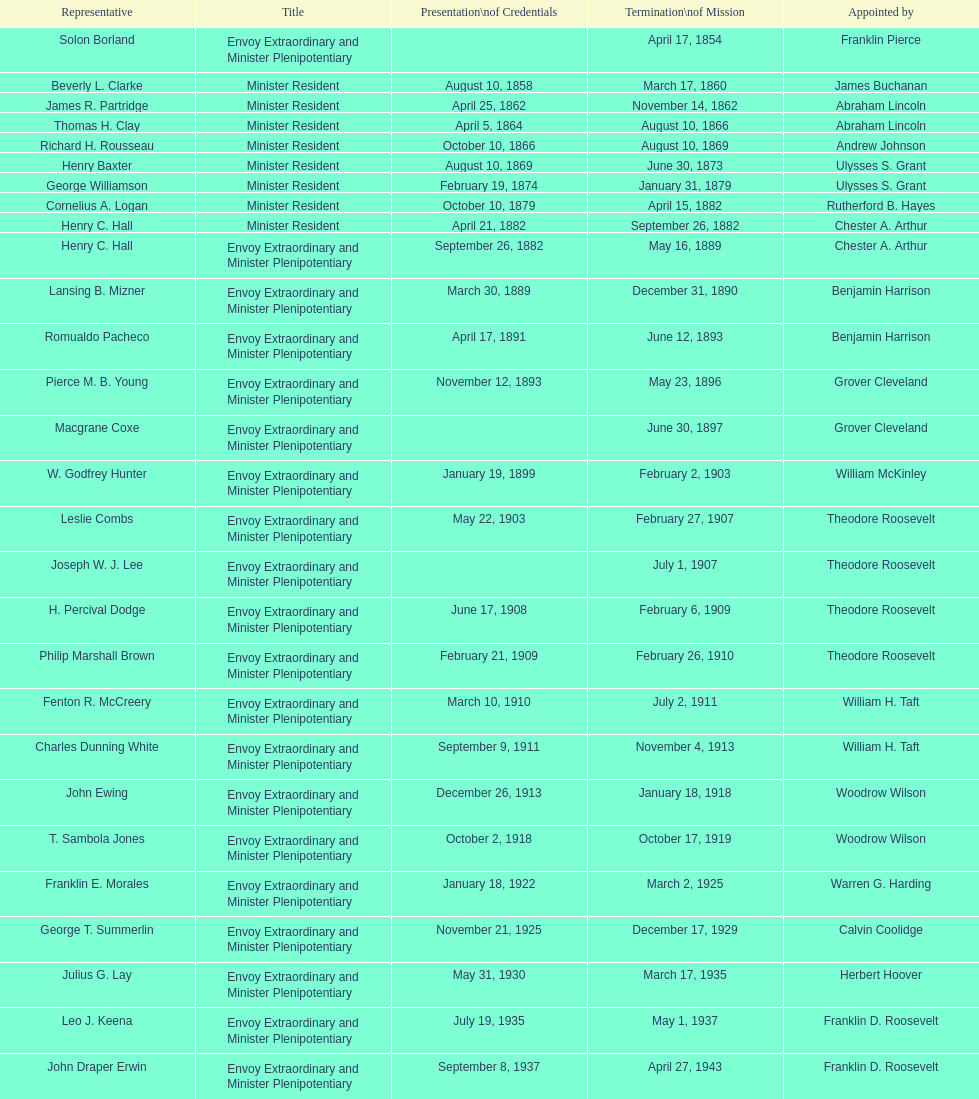Who was the final representative selected? Lisa Kubiske. 